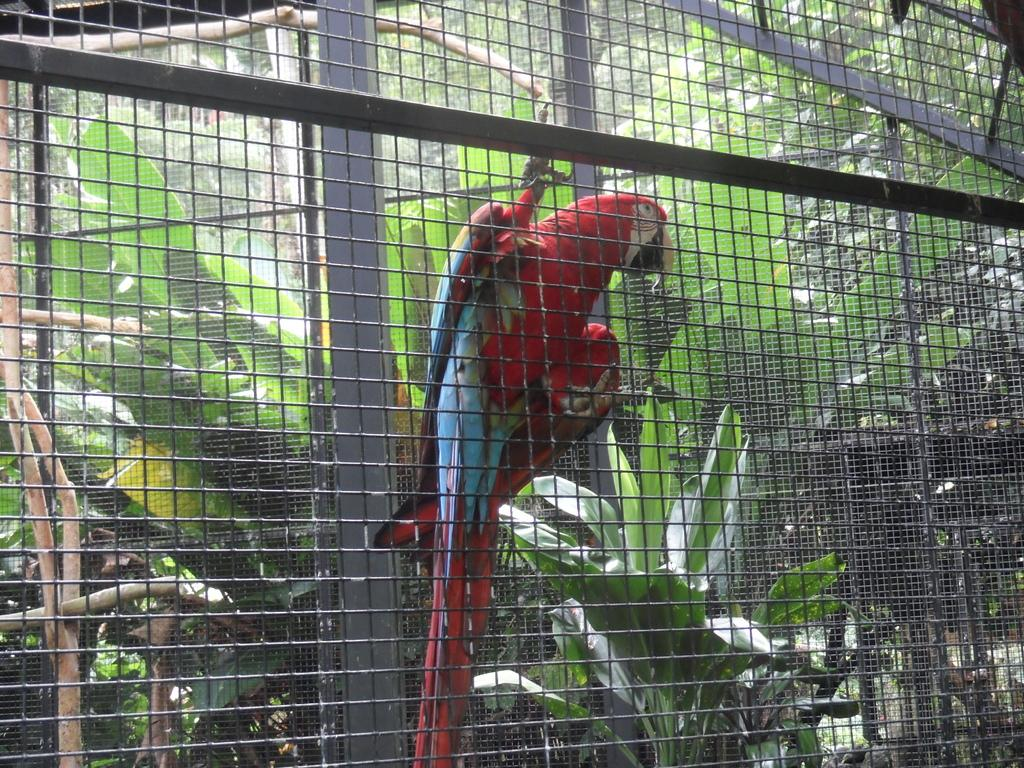What is inside the cage in the image? There is a bird inside the cage in the image. What colors does the bird have? The bird has blue and red colors. What can be seen in the background of the image? There are plants in the background of the image. What color are the plants in the image? The plants are green in color. How does the bird say good-bye to the plants in the image? The bird does not say good-bye to the plants in the image, as birds do not have the ability to communicate using human language. 